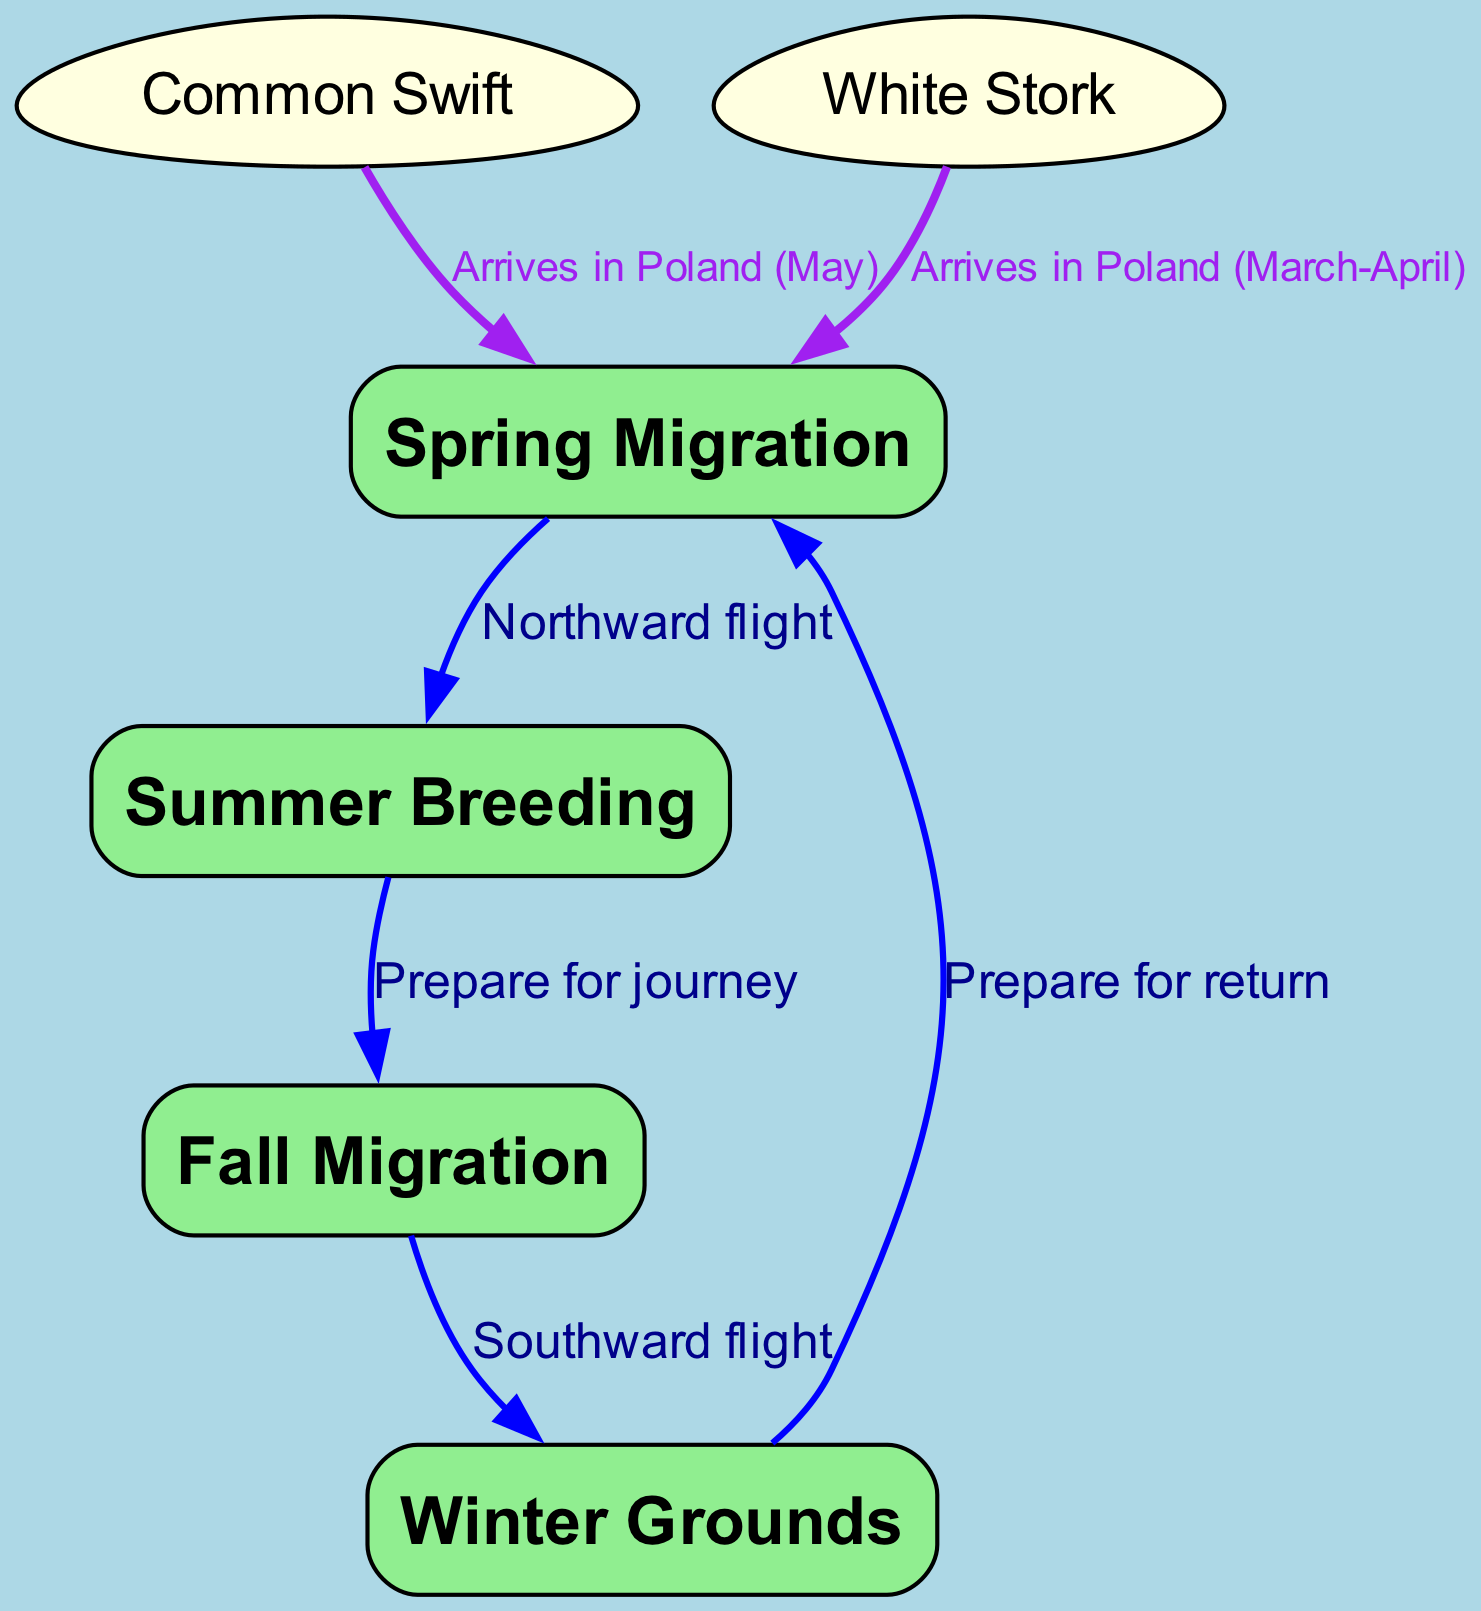What are the four main stages of bird migration shown in the diagram? The diagram includes four stages of bird migration: Spring Migration, Summer Breeding, Fall Migration, and Winter Grounds. These stages are labeled as nodes in the diagram.
Answer: Spring Migration, Summer Breeding, Fall Migration, Winter Grounds How many birds are represented in the diagram? The diagram represents two bird species: Common Swift and White Stork. Each is shown as a node connected to the migration stages.
Answer: 2 What is the label of the edge connecting Spring Migration to Summer Breeding? The edge connecting Spring Migration to Summer Breeding is labeled "Northward flight." This label indicates the direction of the birds' movement during this period.
Answer: Northward flight Which bird arrives in Poland in May? The Common Swift is the bird that arrives in Poland in May, as indicated by the specific edge in the diagram that connects it to Spring Migration.
Answer: Common Swift What transition occurs between Summer Breeding and Fall Migration? The transition between Summer Breeding and Fall Migration is labeled "Prepare for journey." This signifies the birds' preparation for the next phase of migration.
Answer: Prepare for journey How does the White Stork get to Spring Migration? The White Stork arrives in Poland during March-April, as specified in the edge connecting it to Spring Migration. This indicates its timing for entering this phase.
Answer: Arrives in Poland (March-April) What direction do birds travel during Fall Migration? During Fall Migration, birds travel in a Southward direction, as denoted by the label on the edge connected to this migration phase.
Answer: Southward flight How does the diagram visually differentiate between seasons and bird species? The diagram differentiates seasons using rectangular nodes filled with light green, while bird species are represented as egg-shaped nodes filled with light yellow. This visual distinction helps in understanding the context of each node.
Answer: Rectangular for seasons, egg-shaped for birds 